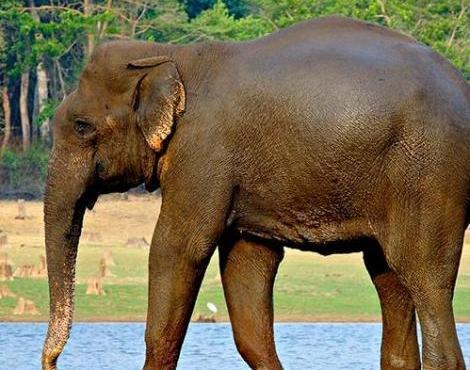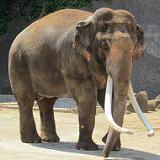The first image is the image on the left, the second image is the image on the right. Examine the images to the left and right. Is the description "At least one of the elephants does not have tusks." accurate? Answer yes or no. Yes. The first image is the image on the left, the second image is the image on the right. Assess this claim about the two images: "Each image shows a single elephant, and all elephants have tusks.". Correct or not? Answer yes or no. No. 